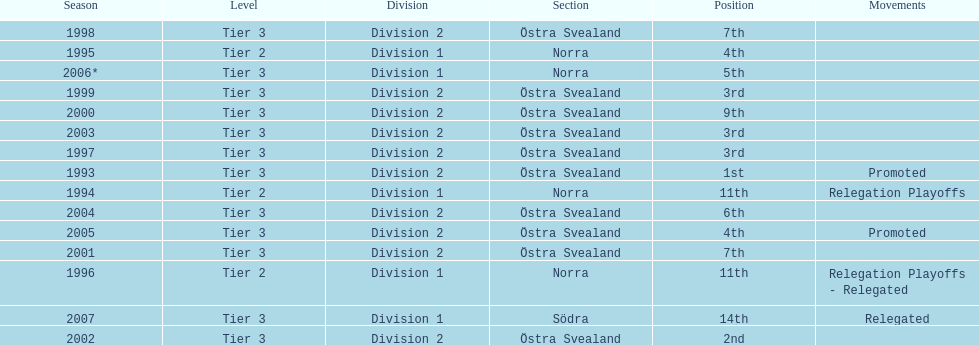In total, how many times were they promoted? 2. 